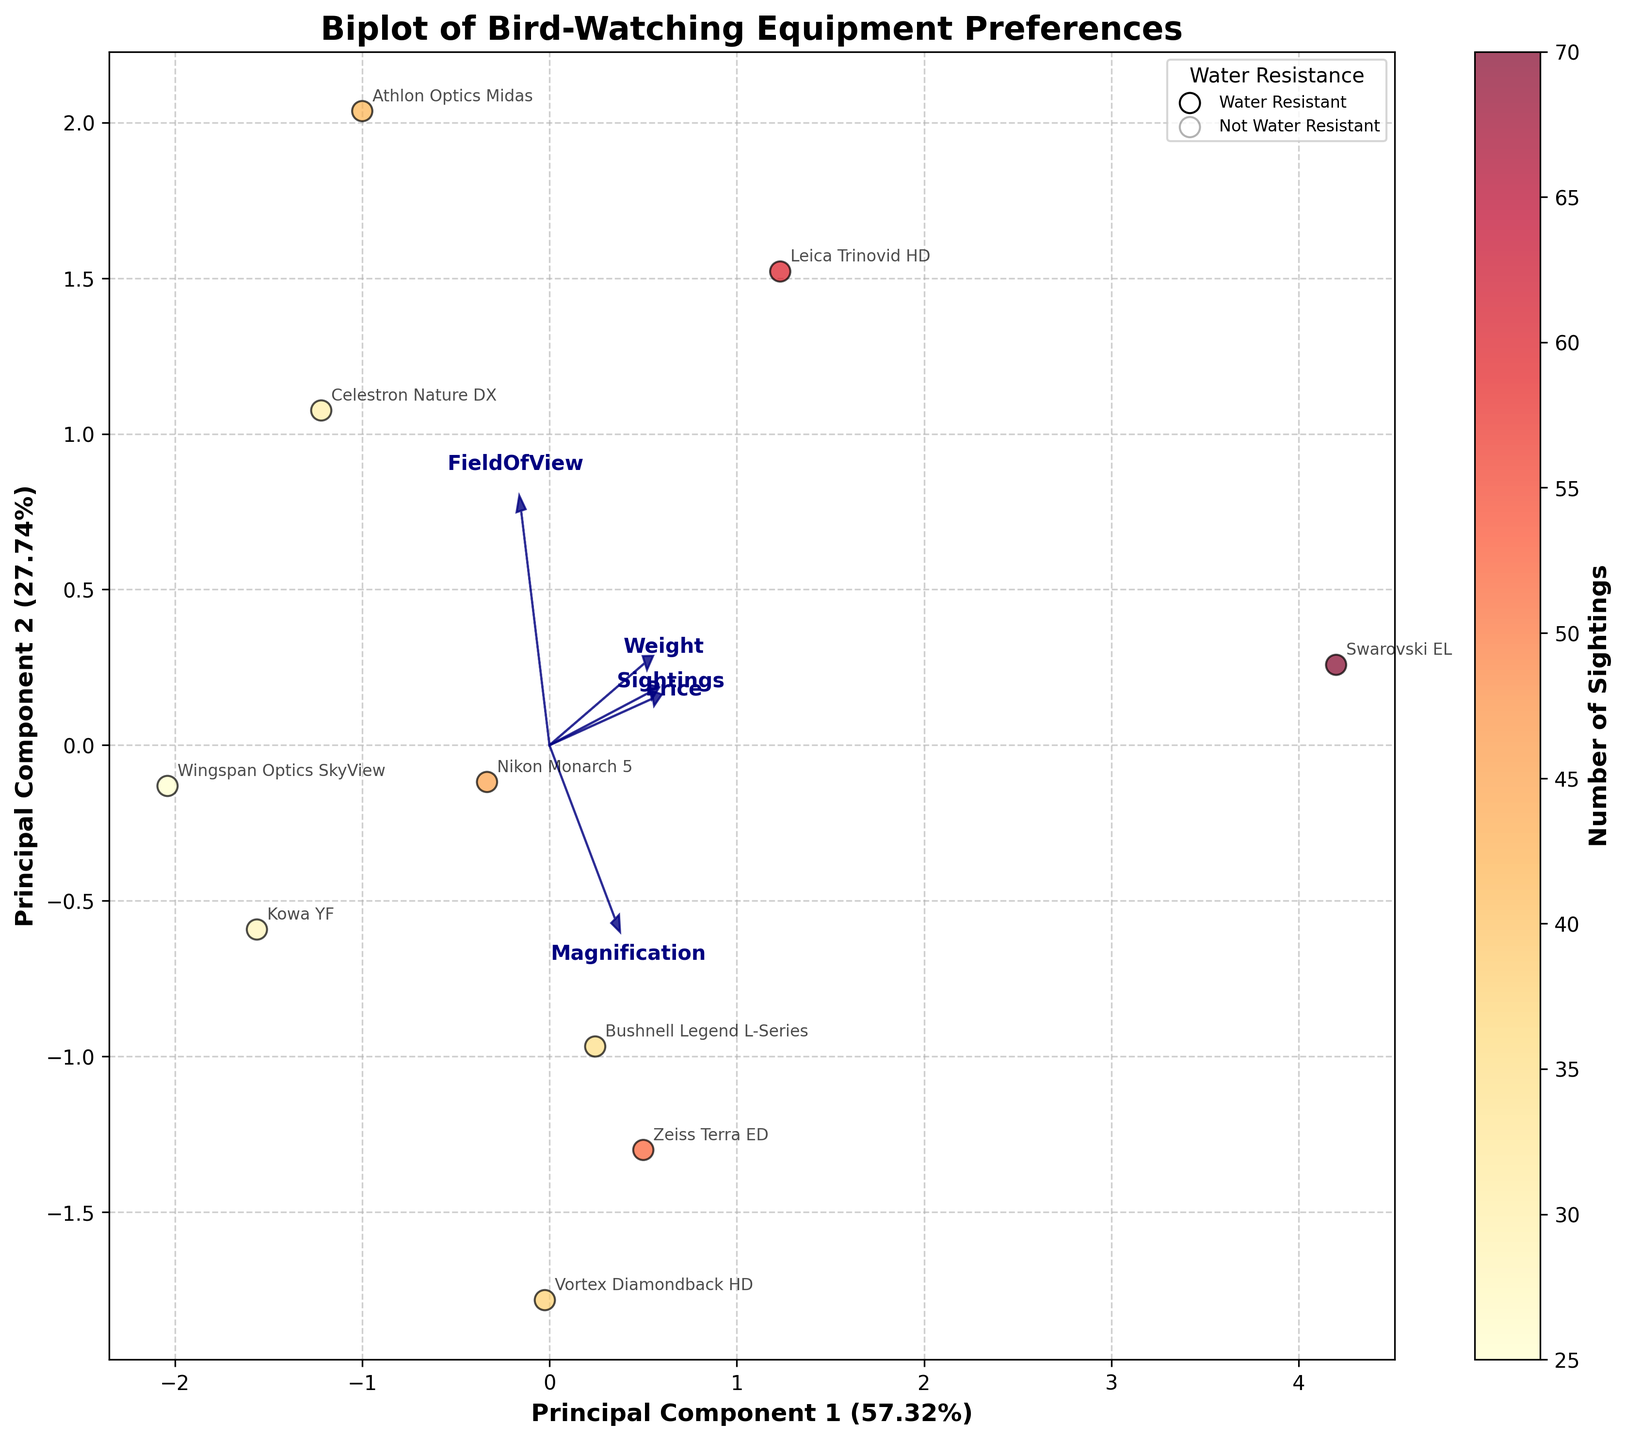How many data points are available in the plot? Count the number of unique equipment labels or data points represented by each dot in the scatter plot.
Answer: 10 What is the color label used to represent data points indicating a higher number of bird sightings? Look at the color bar which corresponds to the number of sightings; the higher numbers are likely represented by darker or warmer colors.
Answer: Darker orange/red Which piece of equipment is positioned furthest along the Principal Component 1 axis? Check the data points' labels along the x-axis (Principal Component 1) for the one with the highest value in that direction.
Answer: Swarovski EL How does magnification correlate with sightings? Observe the direction and length of the arrow labeled "Magnification" compared to the position and color of the data points, as sightings are indicated by color.
Answer: Positive correlation Which equipment is both water-resistant and has relatively fewer sightings? Look for data points with a full circle marker (legend for water resistance) and a cooler color on the color bar indicating fewer sightings.
Answer: Bushnell Legend L-Series What principal component explains more of the variance in the data? Look at the labels of the axes, which detail the explained variance percentages.
Answer: Principal Component 1 Is there any equipment that is both light in weight and has a broad field of view? Find arrows representing "Weight" and "FieldOfView" and identify the data points near the end of the "Weight" vector (towards the lower weight) and those aligned closely with the "FieldOfView" arrow direction.
Answer: Wingspan Optics SkyView Which equipment shows a strong correlation with the price variable? Observe the direction and overlap of the Price arrow with data points to identify strong positive or negative alignment.
Answer: Leica Trinovid HD Are higher-priced binoculars generally associated with higher numbers of sightings? Compare the positions of data points towards the positive direction of the Price arrow with their comparative colors (representing more sightings).
Answer: Yes Which piece of equipment is closest to the origin, and what does it imply in terms of principal component scores? Identify the data point nearest the (0,0) coordinate and interpret that this equipment has scores close to the mean on the principal component axes.
Answer: Kowa YF 